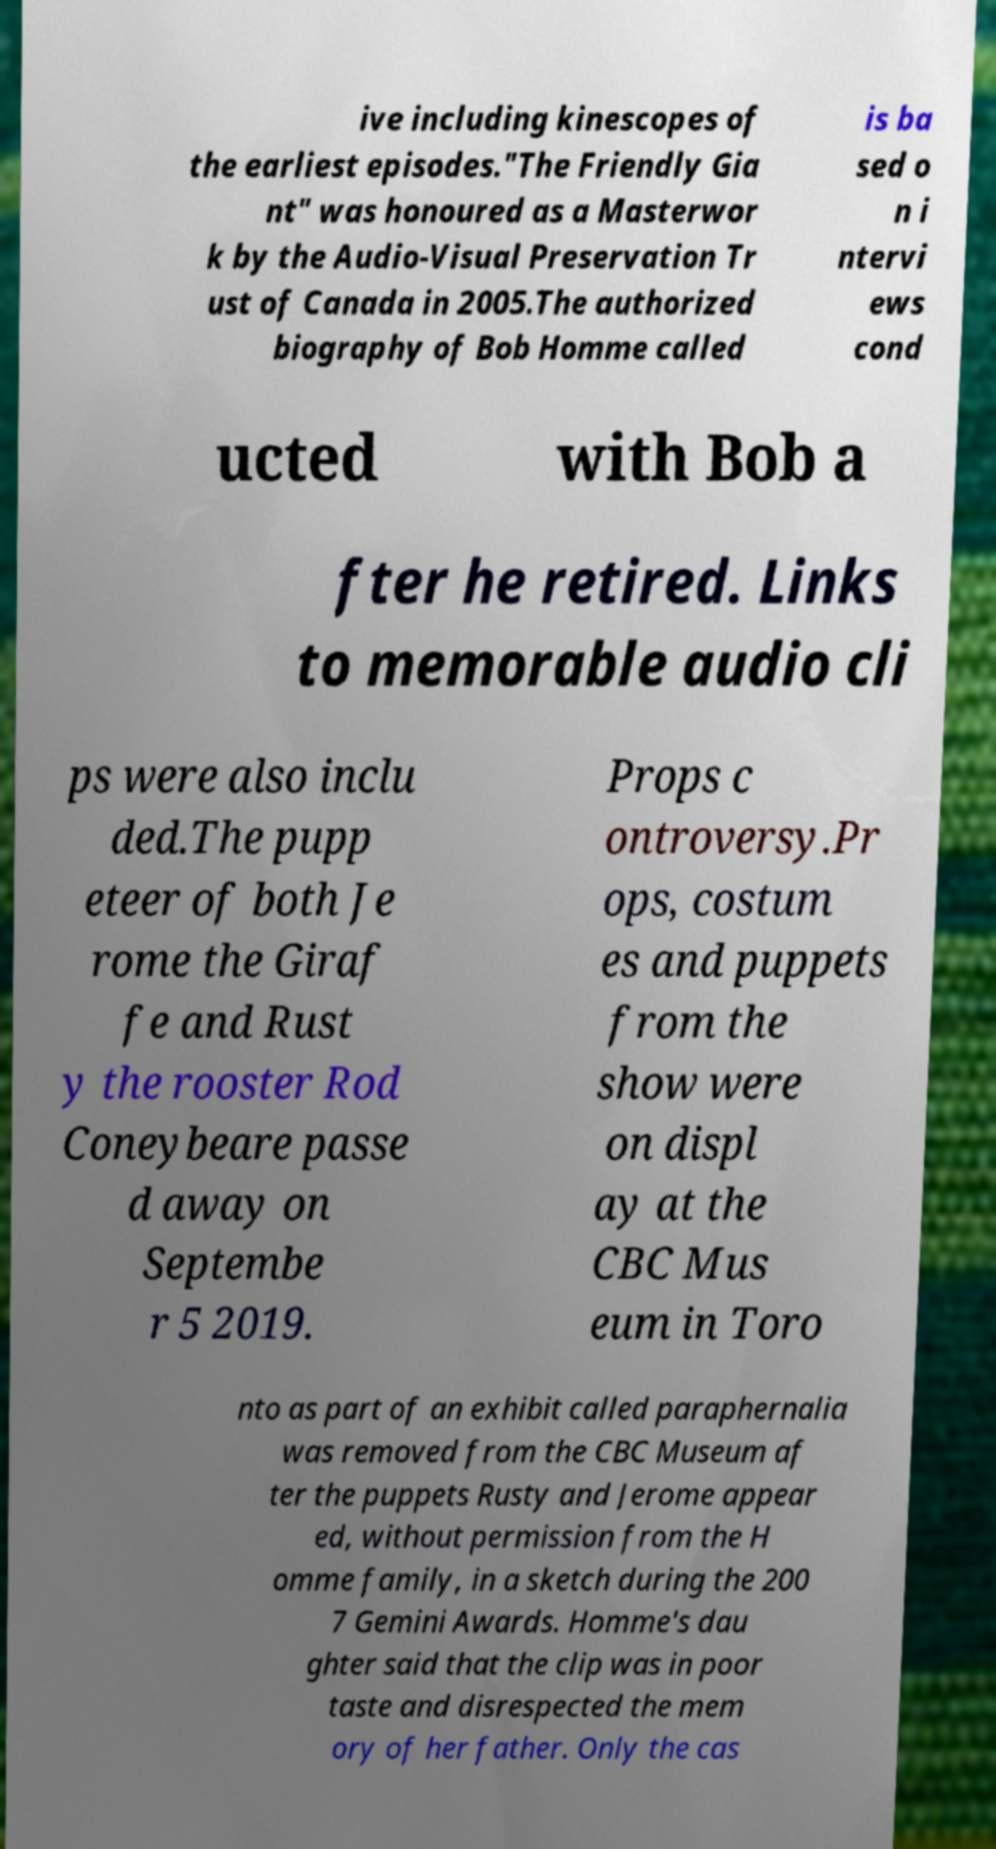Can you read and provide the text displayed in the image?This photo seems to have some interesting text. Can you extract and type it out for me? ive including kinescopes of the earliest episodes."The Friendly Gia nt" was honoured as a Masterwor k by the Audio-Visual Preservation Tr ust of Canada in 2005.The authorized biography of Bob Homme called is ba sed o n i ntervi ews cond ucted with Bob a fter he retired. Links to memorable audio cli ps were also inclu ded.The pupp eteer of both Je rome the Giraf fe and Rust y the rooster Rod Coneybeare passe d away on Septembe r 5 2019. Props c ontroversy.Pr ops, costum es and puppets from the show were on displ ay at the CBC Mus eum in Toro nto as part of an exhibit called paraphernalia was removed from the CBC Museum af ter the puppets Rusty and Jerome appear ed, without permission from the H omme family, in a sketch during the 200 7 Gemini Awards. Homme's dau ghter said that the clip was in poor taste and disrespected the mem ory of her father. Only the cas 